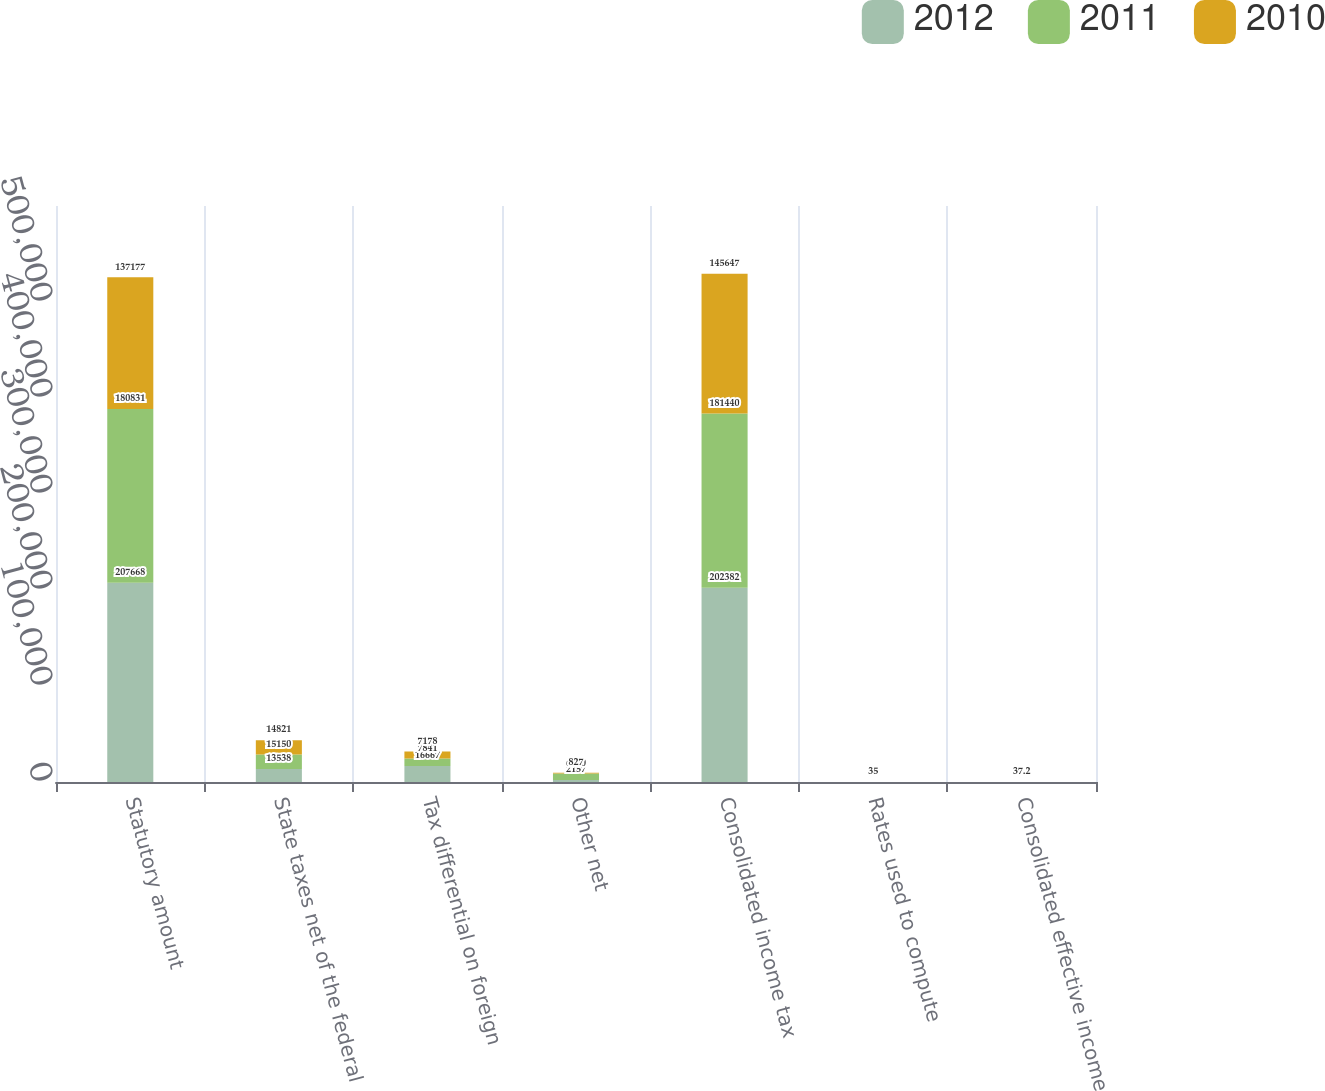Convert chart. <chart><loc_0><loc_0><loc_500><loc_500><stacked_bar_chart><ecel><fcel>Statutory amount<fcel>State taxes net of the federal<fcel>Tax differential on foreign<fcel>Other net<fcel>Consolidated income tax<fcel>Rates used to compute<fcel>Consolidated effective income<nl><fcel>2012<fcel>207668<fcel>13538<fcel>16667<fcel>2157<fcel>202382<fcel>35<fcel>34.1<nl><fcel>2011<fcel>180831<fcel>15150<fcel>7841<fcel>6700<fcel>181440<fcel>35<fcel>35.1<nl><fcel>2010<fcel>137177<fcel>14821<fcel>7178<fcel>827<fcel>145647<fcel>35<fcel>37.2<nl></chart> 